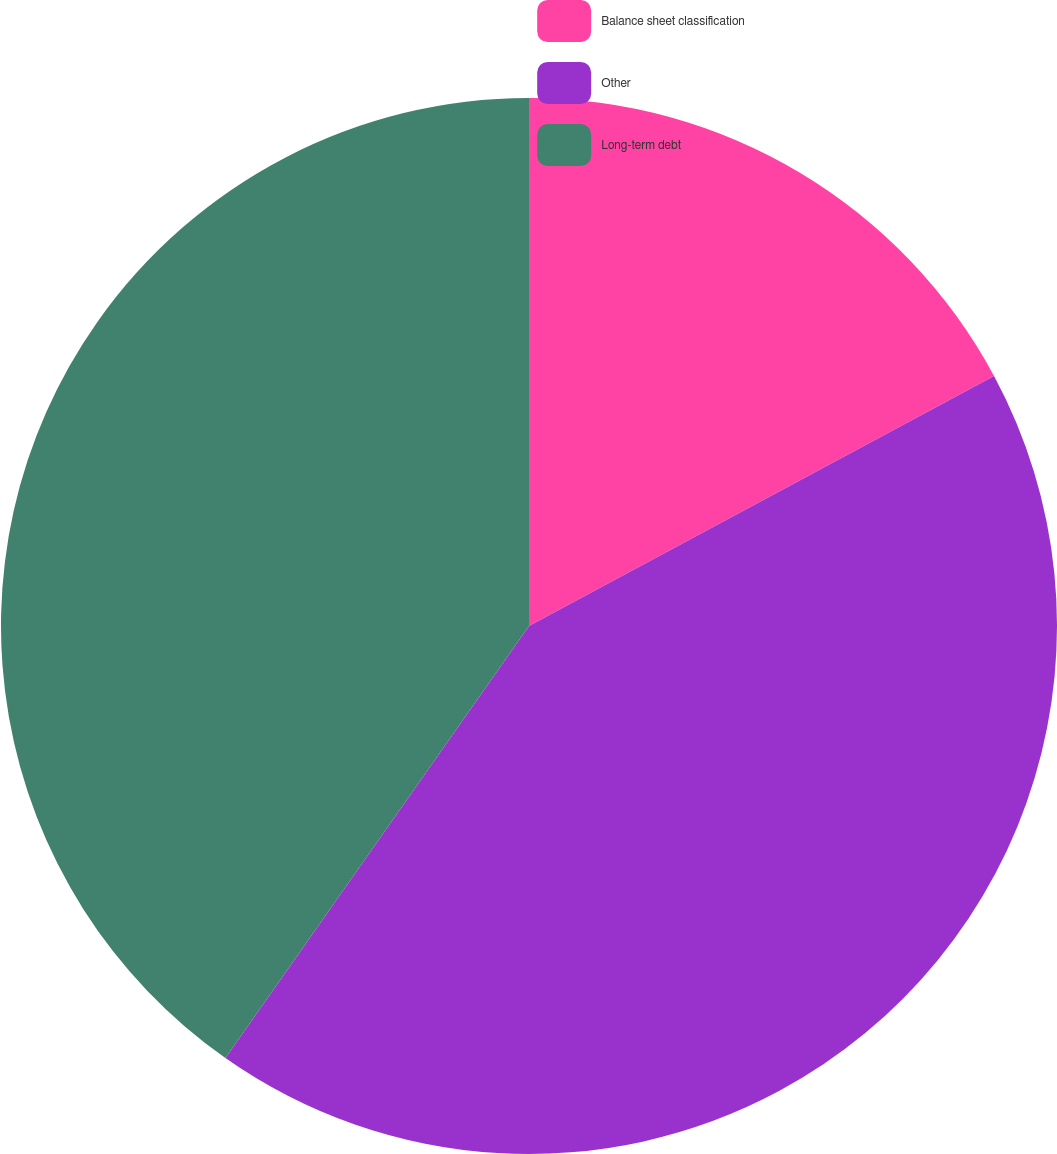<chart> <loc_0><loc_0><loc_500><loc_500><pie_chart><fcel>Balance sheet classification<fcel>Other<fcel>Long-term debt<nl><fcel>17.15%<fcel>42.6%<fcel>40.25%<nl></chart> 